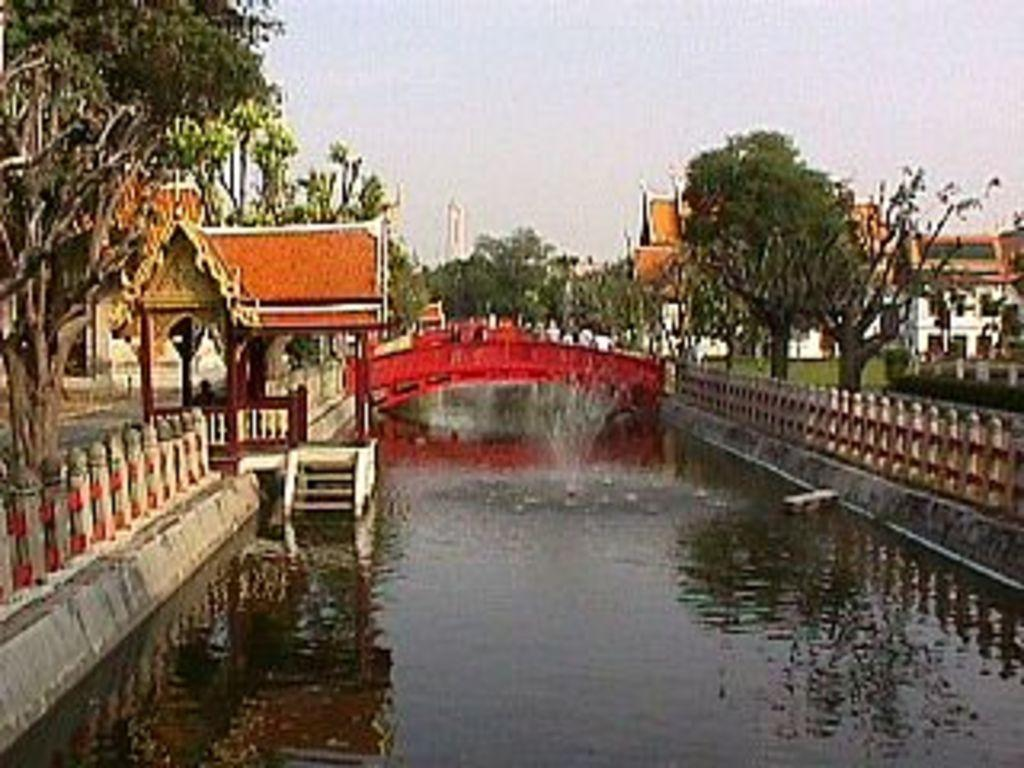What can be seen in the sky in the image? The sky is visible in the image, but no specific details about the sky can be determined from the provided facts. What type of vegetation is present in the image? There are trees in the image. What is the water feature in the image? There is water in the image, but the specific type of water feature (e.g., river, lake, pond) cannot be determined from the provided facts. What structure is present in the image that connects two areas? There is a bridge in the image that connects two areas. What safety feature is present in the image? Railings are present in the image, which may serve as a safety feature. What type of buildings can be seen in the image? Houses are visible in the image. What top-secret discovery can be seen in the image? There is no mention of a top-secret discovery in the provided facts, so it cannot be determined from the image. What way is the bridge positioned in the image? The provided facts do not specify the orientation or position of the bridge, so it cannot be determined from the image. 